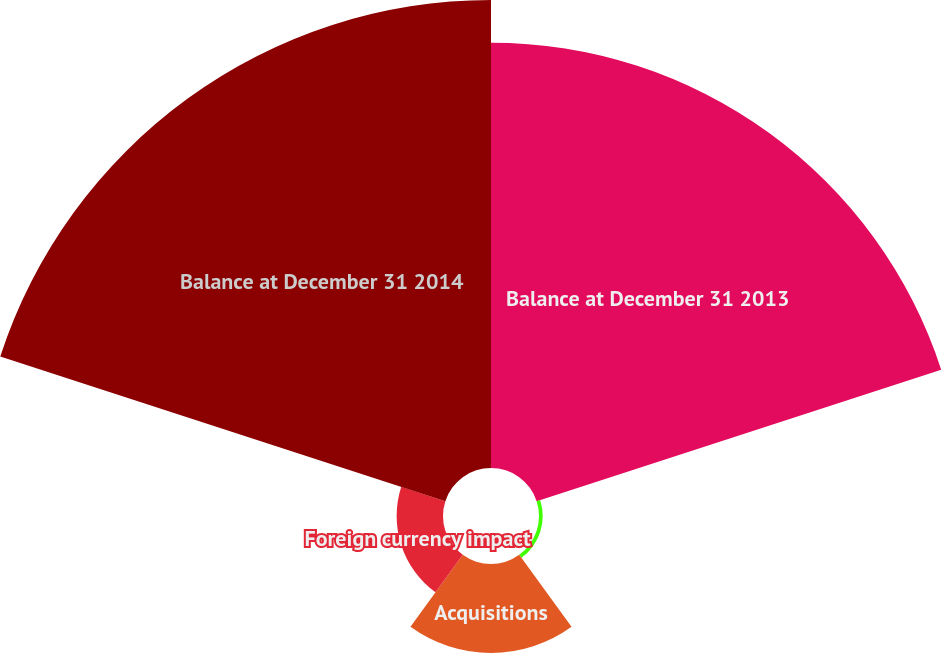Convert chart to OTSL. <chart><loc_0><loc_0><loc_500><loc_500><pie_chart><fcel>Balance at December 31 2013<fcel>Adjustment to preliminary<fcel>Acquisitions<fcel>Foreign currency impact<fcel>Balance at December 31 2014<nl><fcel>41.2%<fcel>0.36%<fcel>8.62%<fcel>4.49%<fcel>45.33%<nl></chart> 